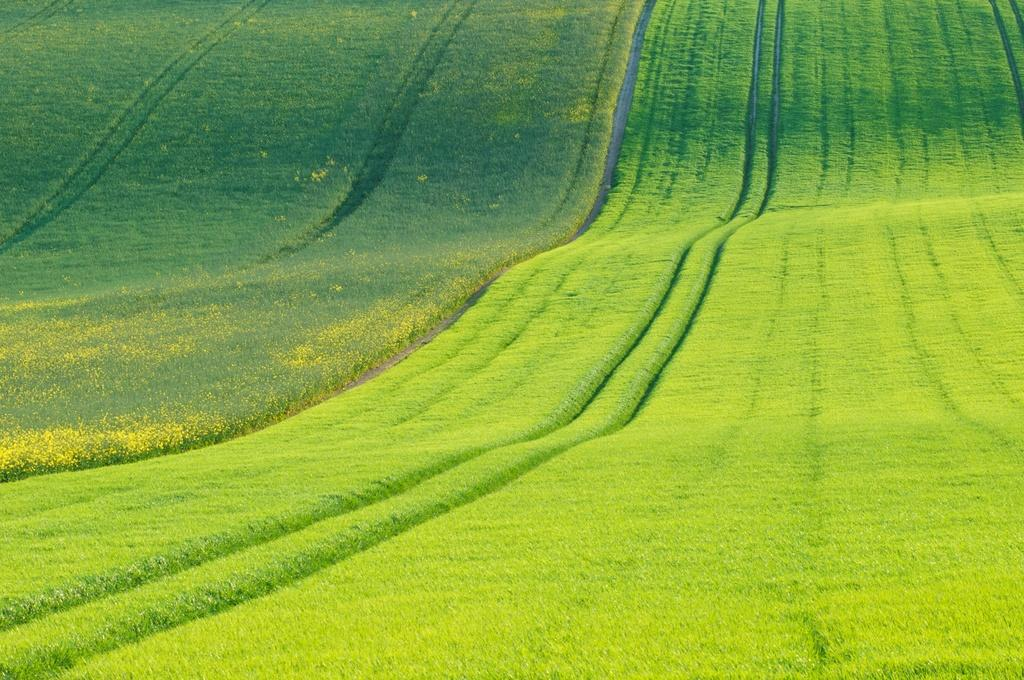What type of landscape is depicted in the image? The image shows fields. Are there any specific features within the fields? Yes, there are paths in the middle of the fields. What type of vest is being worn by the mist in the image? There is no mist or vest present in the image. The image only shows fields with paths in the middle. 